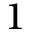<formula> <loc_0><loc_0><loc_500><loc_500>1</formula> 